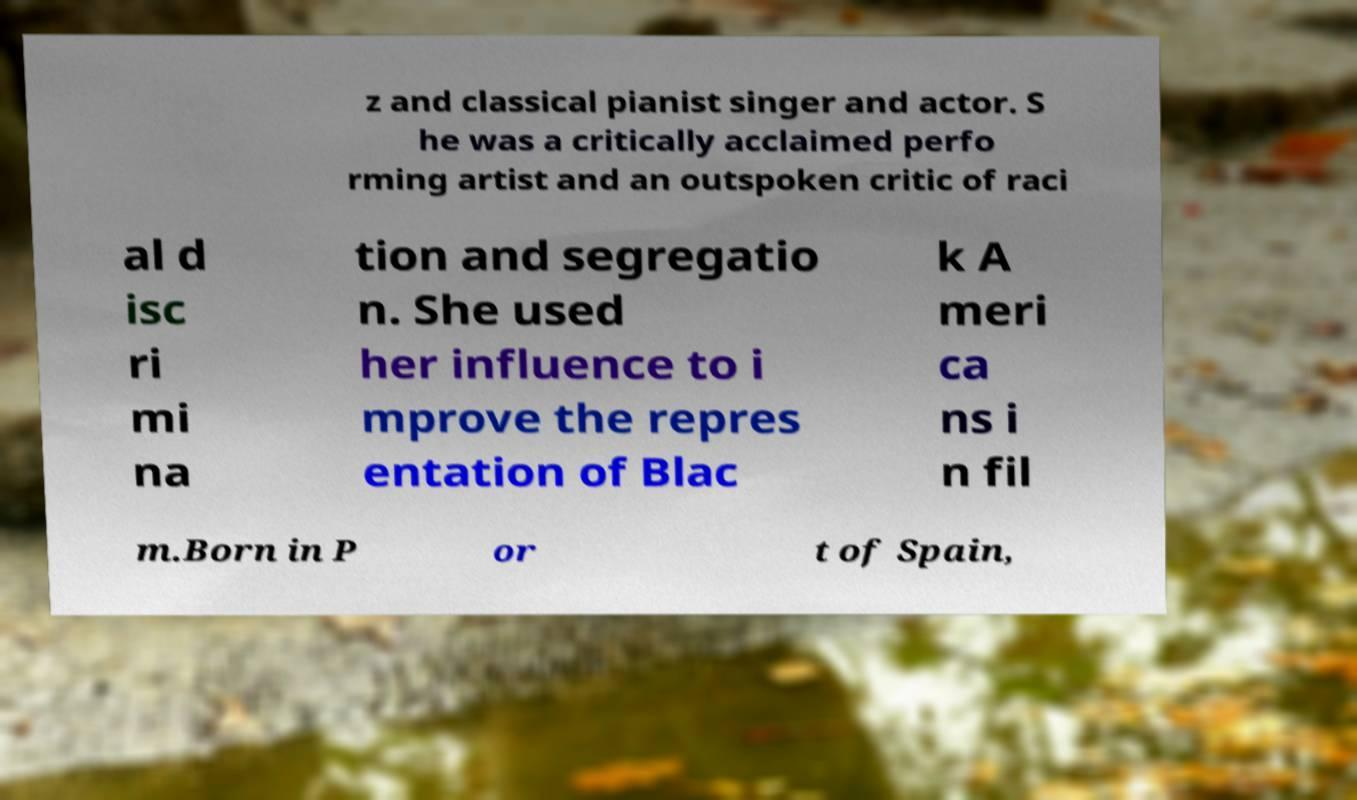Could you extract and type out the text from this image? z and classical pianist singer and actor. S he was a critically acclaimed perfo rming artist and an outspoken critic of raci al d isc ri mi na tion and segregatio n. She used her influence to i mprove the repres entation of Blac k A meri ca ns i n fil m.Born in P or t of Spain, 